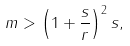<formula> <loc_0><loc_0><loc_500><loc_500>m > \left ( 1 + \frac { s } { r } \right ) ^ { 2 } s ,</formula> 